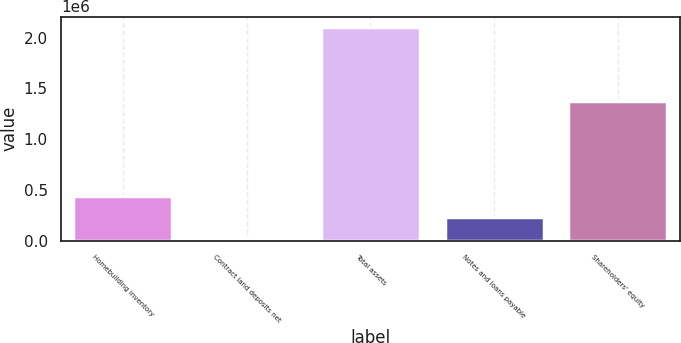<chart> <loc_0><loc_0><loc_500><loc_500><bar_chart><fcel>Homebuilding inventory<fcel>Contract land deposits net<fcel>Total assets<fcel>Notes and loans payable<fcel>Shareholders' equity<nl><fcel>443906<fcel>29073<fcel>2.10324e+06<fcel>236489<fcel>1.37379e+06<nl></chart> 